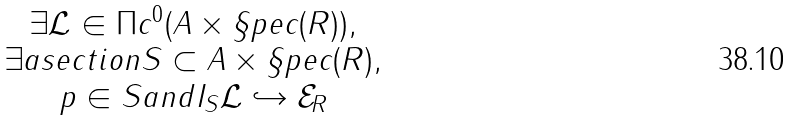<formula> <loc_0><loc_0><loc_500><loc_500>\begin{matrix} \exists \mathcal { L } \in \Pi c ^ { 0 } ( A \times \S p e c ( R ) ) , \\ \exists a s e c t i o n S \subset A \times \S p e c ( R ) , \\ p \in S a n d I _ { S } \mathcal { L } \hookrightarrow \mathcal { E } _ { R } \end{matrix}</formula> 